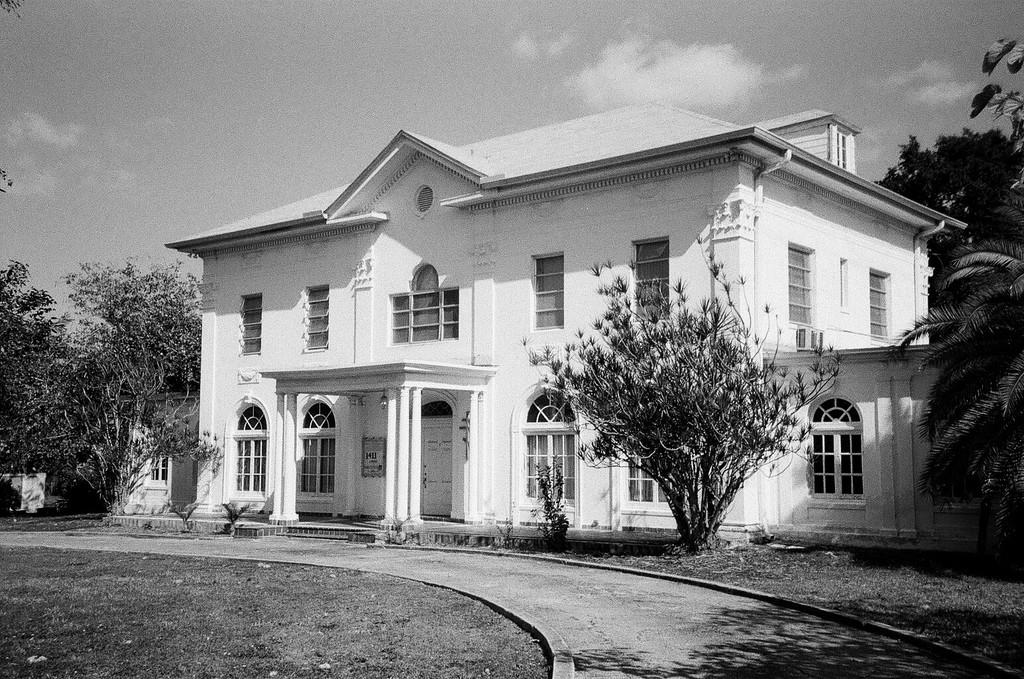What type of structure is visible in the image? There is a building in the image. What can be seen on the left side of the image? There are trees on the left side of the image. What can be seen on the right side of the image? There are trees on the right side of the image. What is visible at the top of the image? The sky is visible at the top of the image. How is the image presented in terms of color? The image is in black and white. What day of the week is depicted on the calendar in the image? There is no calendar present in the image, so it is not possible to determine the day of the week. 